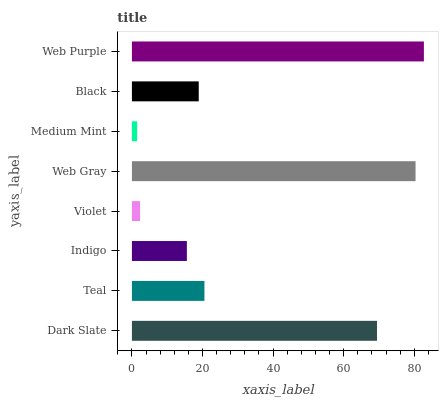Is Medium Mint the minimum?
Answer yes or no. Yes. Is Web Purple the maximum?
Answer yes or no. Yes. Is Teal the minimum?
Answer yes or no. No. Is Teal the maximum?
Answer yes or no. No. Is Dark Slate greater than Teal?
Answer yes or no. Yes. Is Teal less than Dark Slate?
Answer yes or no. Yes. Is Teal greater than Dark Slate?
Answer yes or no. No. Is Dark Slate less than Teal?
Answer yes or no. No. Is Teal the high median?
Answer yes or no. Yes. Is Black the low median?
Answer yes or no. Yes. Is Indigo the high median?
Answer yes or no. No. Is Web Purple the low median?
Answer yes or no. No. 